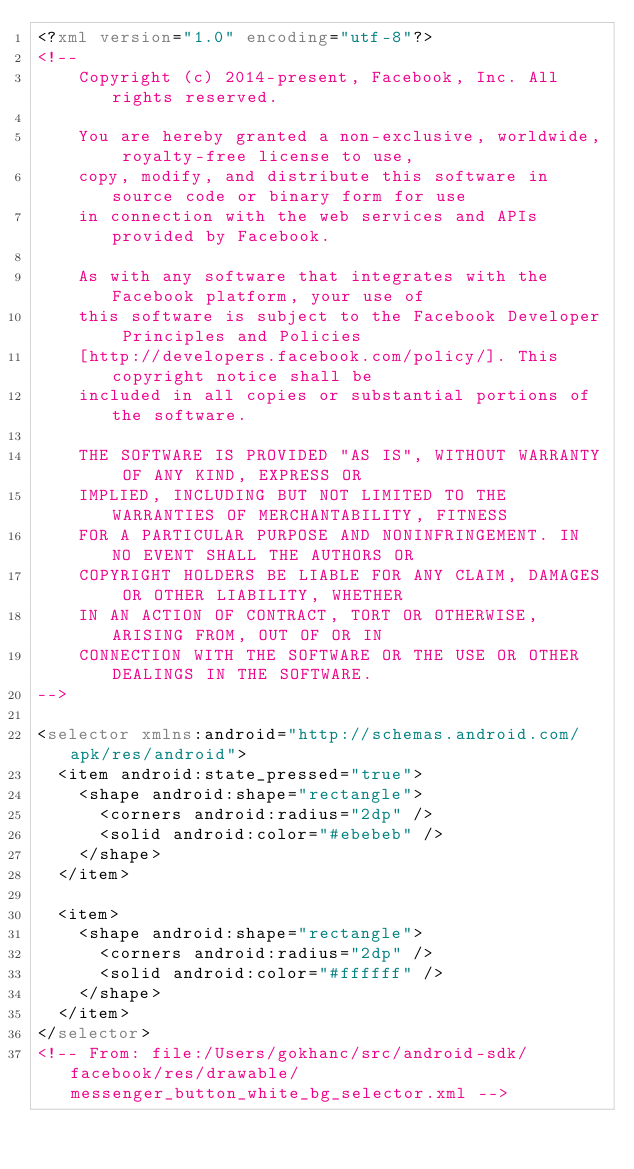<code> <loc_0><loc_0><loc_500><loc_500><_XML_><?xml version="1.0" encoding="utf-8"?>
<!--
    Copyright (c) 2014-present, Facebook, Inc. All rights reserved.

    You are hereby granted a non-exclusive, worldwide, royalty-free license to use,
    copy, modify, and distribute this software in source code or binary form for use
    in connection with the web services and APIs provided by Facebook.

    As with any software that integrates with the Facebook platform, your use of
    this software is subject to the Facebook Developer Principles and Policies
    [http://developers.facebook.com/policy/]. This copyright notice shall be
    included in all copies or substantial portions of the software.

    THE SOFTWARE IS PROVIDED "AS IS", WITHOUT WARRANTY OF ANY KIND, EXPRESS OR
    IMPLIED, INCLUDING BUT NOT LIMITED TO THE WARRANTIES OF MERCHANTABILITY, FITNESS
    FOR A PARTICULAR PURPOSE AND NONINFRINGEMENT. IN NO EVENT SHALL THE AUTHORS OR
    COPYRIGHT HOLDERS BE LIABLE FOR ANY CLAIM, DAMAGES OR OTHER LIABILITY, WHETHER
    IN AN ACTION OF CONTRACT, TORT OR OTHERWISE, ARISING FROM, OUT OF OR IN
    CONNECTION WITH THE SOFTWARE OR THE USE OR OTHER DEALINGS IN THE SOFTWARE.
-->

<selector xmlns:android="http://schemas.android.com/apk/res/android">
  <item android:state_pressed="true">
    <shape android:shape="rectangle">
      <corners android:radius="2dp" />
      <solid android:color="#ebebeb" />
    </shape>
  </item>

  <item>
    <shape android:shape="rectangle">
      <corners android:radius="2dp" />
      <solid android:color="#ffffff" />
    </shape>
  </item>
</selector>
<!-- From: file:/Users/gokhanc/src/android-sdk/facebook/res/drawable/messenger_button_white_bg_selector.xml --></code> 